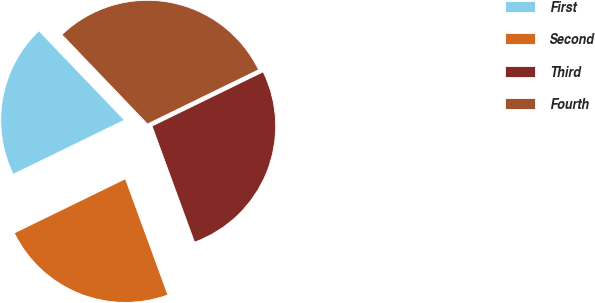Convert chart. <chart><loc_0><loc_0><loc_500><loc_500><pie_chart><fcel>First<fcel>Second<fcel>Third<fcel>Fourth<nl><fcel>20.07%<fcel>23.36%<fcel>26.64%<fcel>29.93%<nl></chart> 